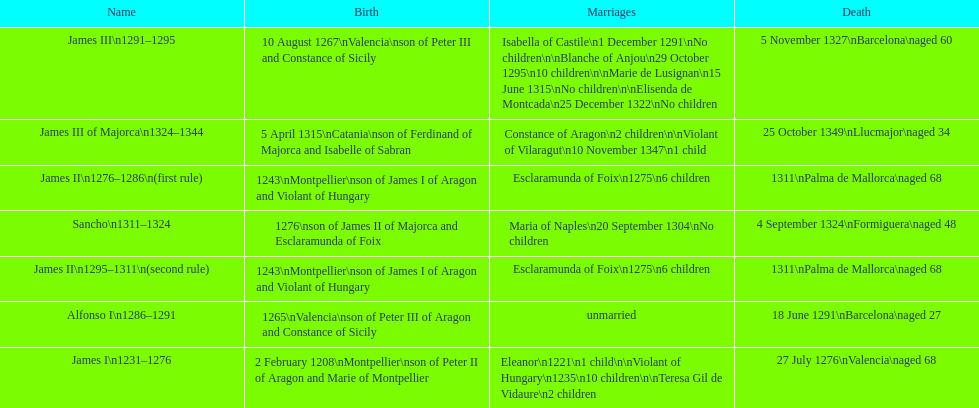Was james iii or sancho born in the year 1276? Sancho. 